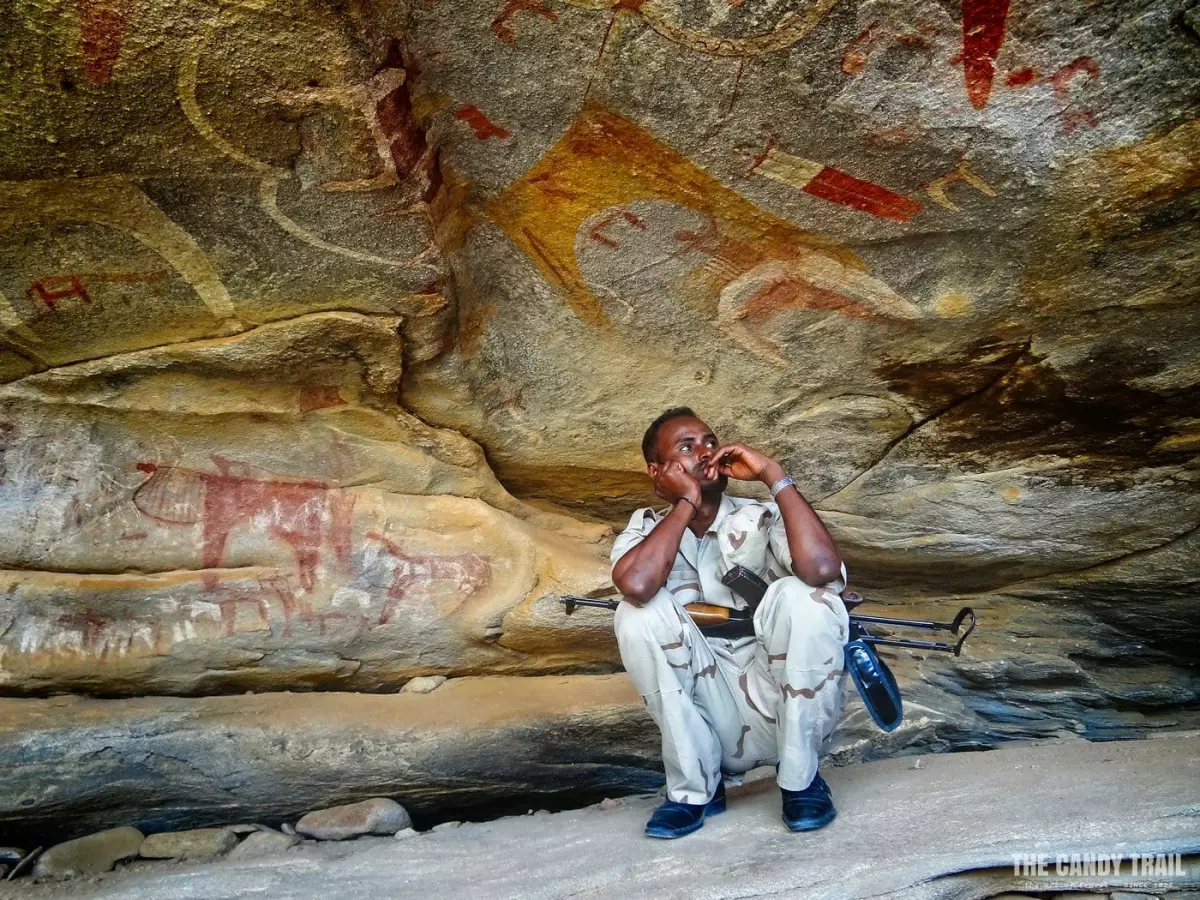Can you describe the rock paintings seen in this image? The rock paintings in this image are ancient artworks depicted in a variety of red hues. They portray a series of animals and anthropomorphic figures that suggest a lively interaction. Some animals appear to be in motion, suggesting hunting scenes or communal gatherings, a testament to the societal and ritual significance these paintings held for their creators. 